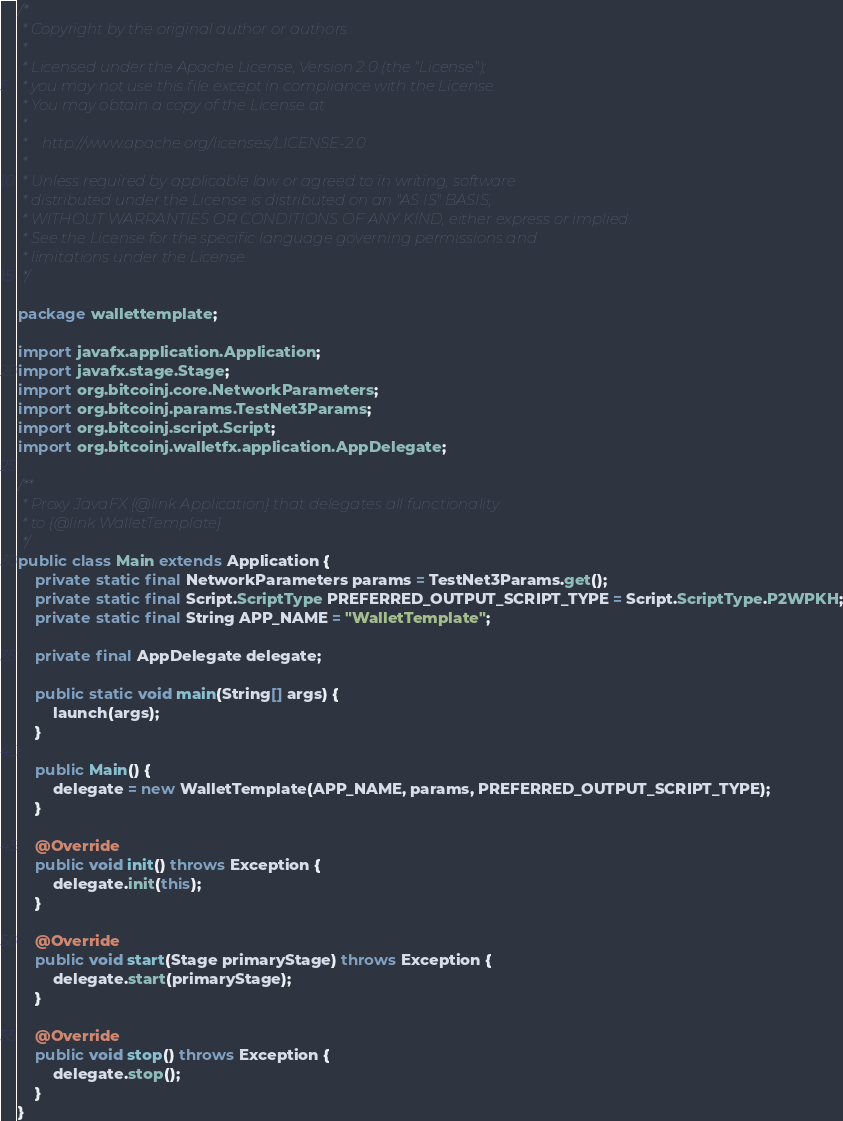<code> <loc_0><loc_0><loc_500><loc_500><_Java_>/*
 * Copyright by the original author or authors.
 * 
 * Licensed under the Apache License, Version 2.0 (the "License");
 * you may not use this file except in compliance with the License.
 * You may obtain a copy of the License at
 *
 *    http://www.apache.org/licenses/LICENSE-2.0
 *
 * Unless required by applicable law or agreed to in writing, software
 * distributed under the License is distributed on an "AS IS" BASIS,
 * WITHOUT WARRANTIES OR CONDITIONS OF ANY KIND, either express or implied.
 * See the License for the specific language governing permissions and
 * limitations under the License.
 */

package wallettemplate;

import javafx.application.Application;
import javafx.stage.Stage;
import org.bitcoinj.core.NetworkParameters;
import org.bitcoinj.params.TestNet3Params;
import org.bitcoinj.script.Script;
import org.bitcoinj.walletfx.application.AppDelegate;

/**
 * Proxy JavaFX {@link Application} that delegates all functionality
 * to {@link WalletTemplate}
 */
public class Main extends Application {
    private static final NetworkParameters params = TestNet3Params.get();
    private static final Script.ScriptType PREFERRED_OUTPUT_SCRIPT_TYPE = Script.ScriptType.P2WPKH;
    private static final String APP_NAME = "WalletTemplate";

    private final AppDelegate delegate;

    public static void main(String[] args) {
        launch(args);
    }

    public Main() {
        delegate = new WalletTemplate(APP_NAME, params, PREFERRED_OUTPUT_SCRIPT_TYPE);
    }

    @Override
    public void init() throws Exception {
        delegate.init(this);
    }

    @Override
    public void start(Stage primaryStage) throws Exception {
        delegate.start(primaryStage);
    }

    @Override
    public void stop() throws Exception {
        delegate.stop();
    }
}
</code> 